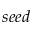<formula> <loc_0><loc_0><loc_500><loc_500>s e e d</formula> 